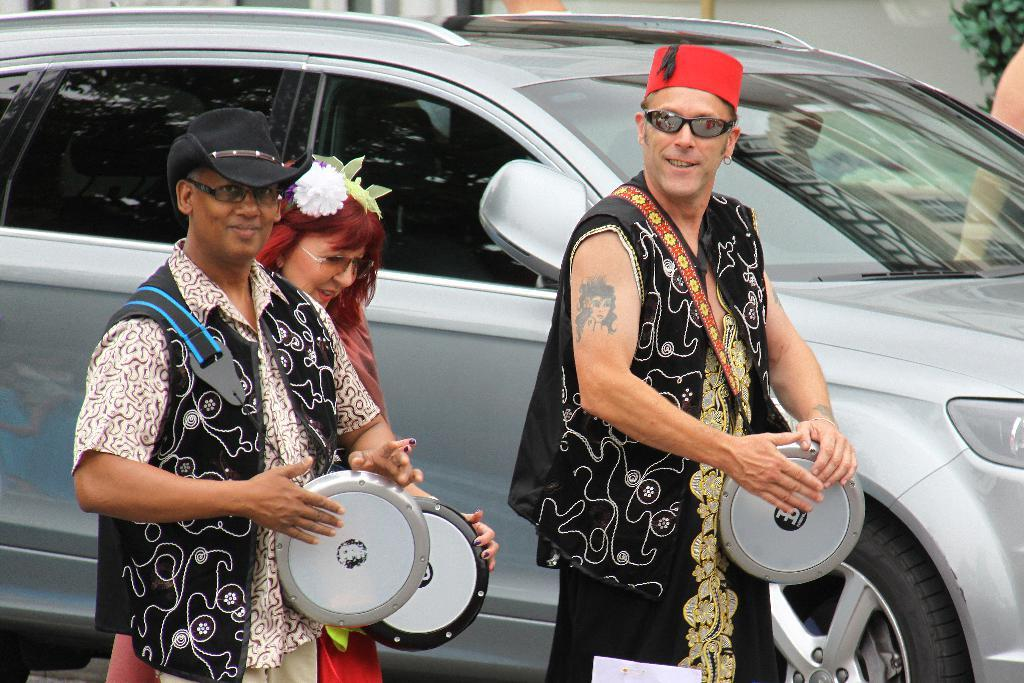How many people are in the image? There are three individuals in the image, two men and a woman. What are the three individuals doing in the image? The three individuals are playing drums. Can you describe anything in the background of the image? Yes, there is a car visible in the background of the image. What type of bun is being used as a drumstick in the image? There is no bun being used as a drumstick in the image; the individuals are using drumsticks or their hands to play the drums. 